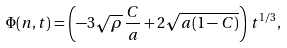Convert formula to latex. <formula><loc_0><loc_0><loc_500><loc_500>\Phi ( n , t ) = \left ( - 3 \sqrt { \rho } \, \frac { C } { a } + 2 \sqrt { a ( 1 - C ) } \right ) \, t ^ { 1 / 3 } ,</formula> 